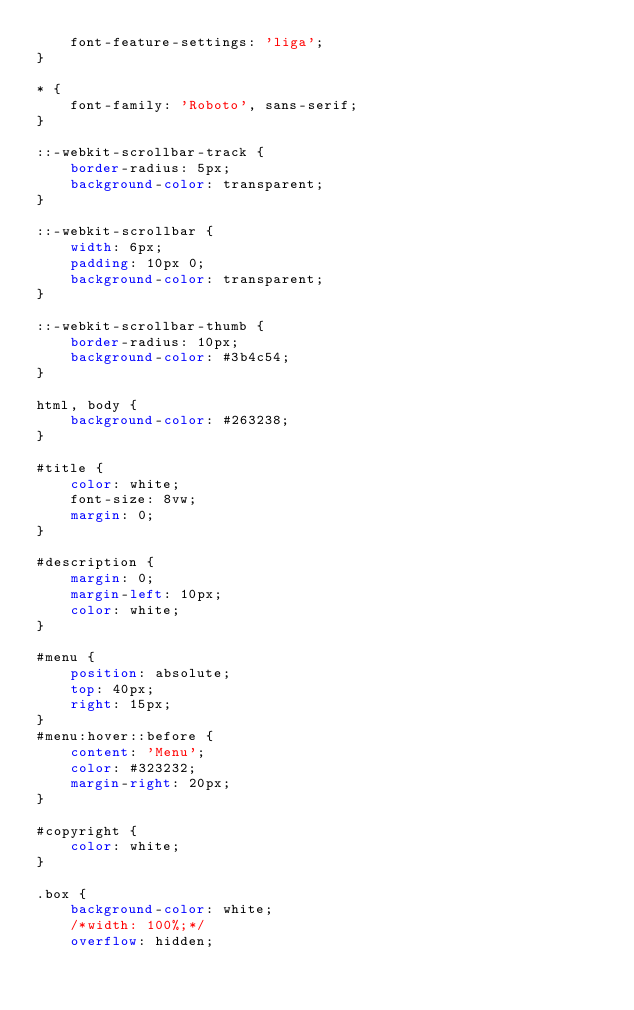<code> <loc_0><loc_0><loc_500><loc_500><_CSS_>    font-feature-settings: 'liga';
}

* {
    font-family: 'Roboto', sans-serif;
}

::-webkit-scrollbar-track {
    border-radius: 5px;
    background-color: transparent;
}

::-webkit-scrollbar {
    width: 6px;
    padding: 10px 0;
    background-color: transparent;
}

::-webkit-scrollbar-thumb {
    border-radius: 10px;
    background-color: #3b4c54;
}

html, body {
    background-color: #263238;
}

#title {
    color: white;
    font-size: 8vw;
    margin: 0;
}

#description {
    margin: 0;
    margin-left: 10px;
    color: white;
}

#menu {
    position: absolute;
    top: 40px;
    right: 15px;
}
#menu:hover::before {
    content: 'Menu';
    color: #323232;
    margin-right: 20px;
}

#copyright {
    color: white;
}

.box {
    background-color: white;
    /*width: 100%;*/
    overflow: hidden;</code> 